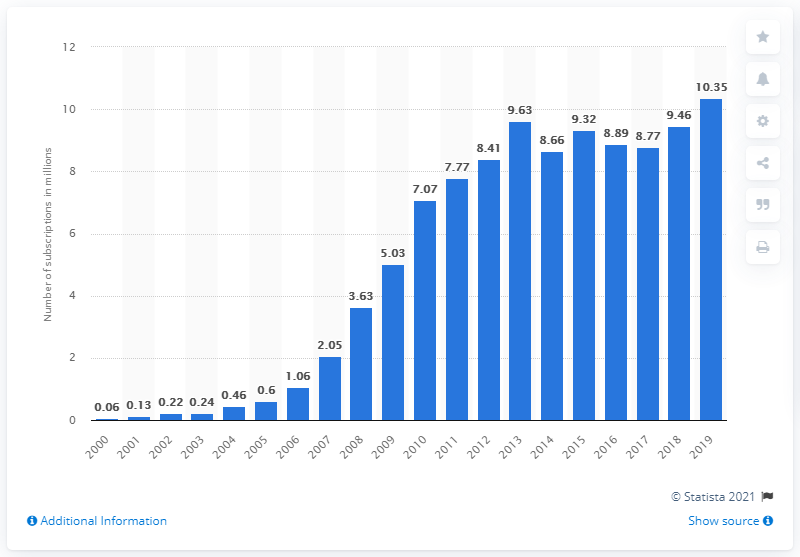Outline some significant characteristics in this image. In 2019, the number of mobile subscriptions in Benin was approximately 10.35. 